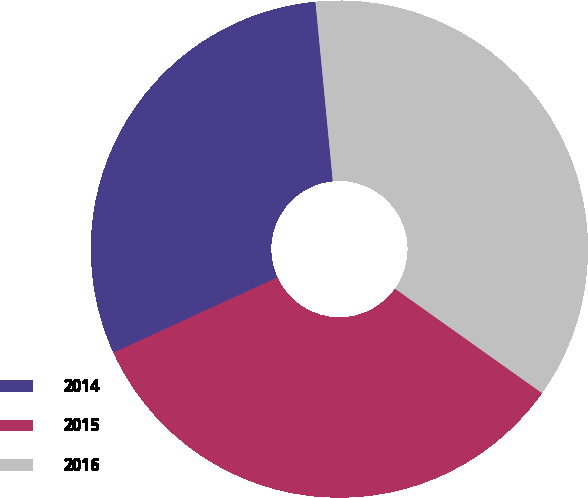Convert chart. <chart><loc_0><loc_0><loc_500><loc_500><pie_chart><fcel>2014<fcel>2015<fcel>2016<nl><fcel>30.3%<fcel>33.33%<fcel>36.36%<nl></chart> 